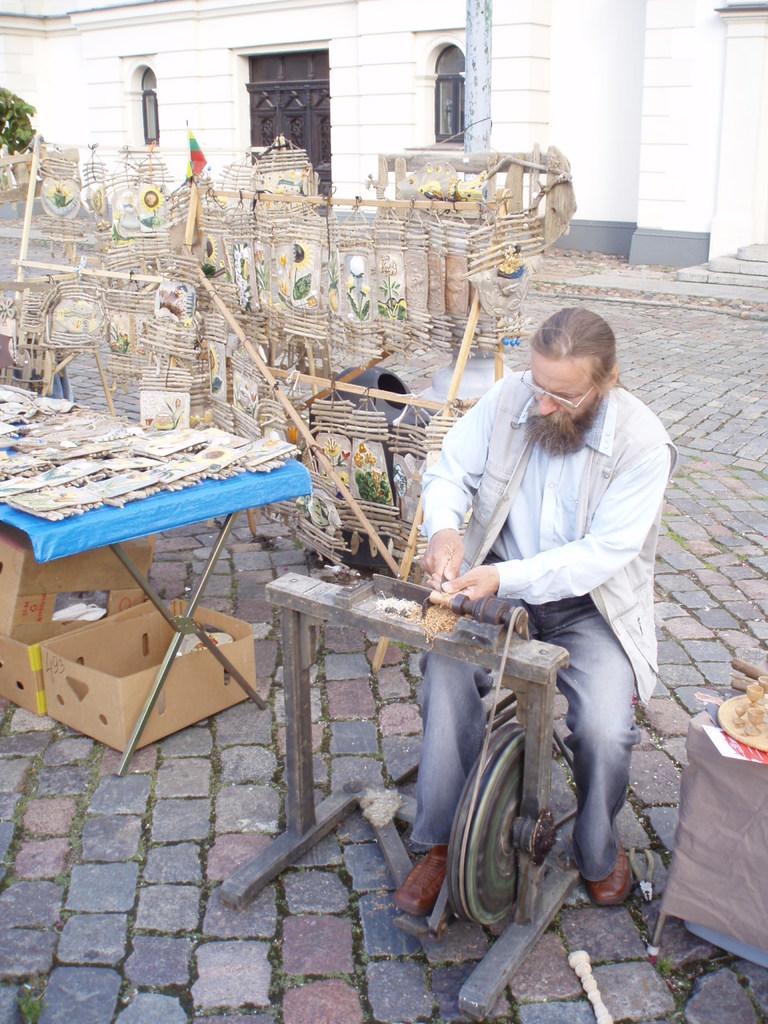Describe this image in one or two sentences. In this image I can see a person with a wood and this is wood machine. On the table there is a wall hanging made by the wood. On the floor there are cardboard boxes. At the back side I can see a building. 